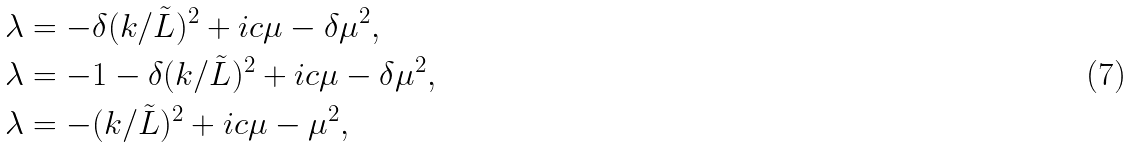<formula> <loc_0><loc_0><loc_500><loc_500>\lambda & = - \delta ( k / \tilde { L } ) ^ { 2 } + i c \mu - \delta \mu ^ { 2 } , \\ \lambda & = - 1 - \delta ( k / \tilde { L } ) ^ { 2 } + i c \mu - \delta \mu ^ { 2 } , \\ \lambda & = - ( k / \tilde { L } ) ^ { 2 } + i c \mu - \mu ^ { 2 } ,</formula> 